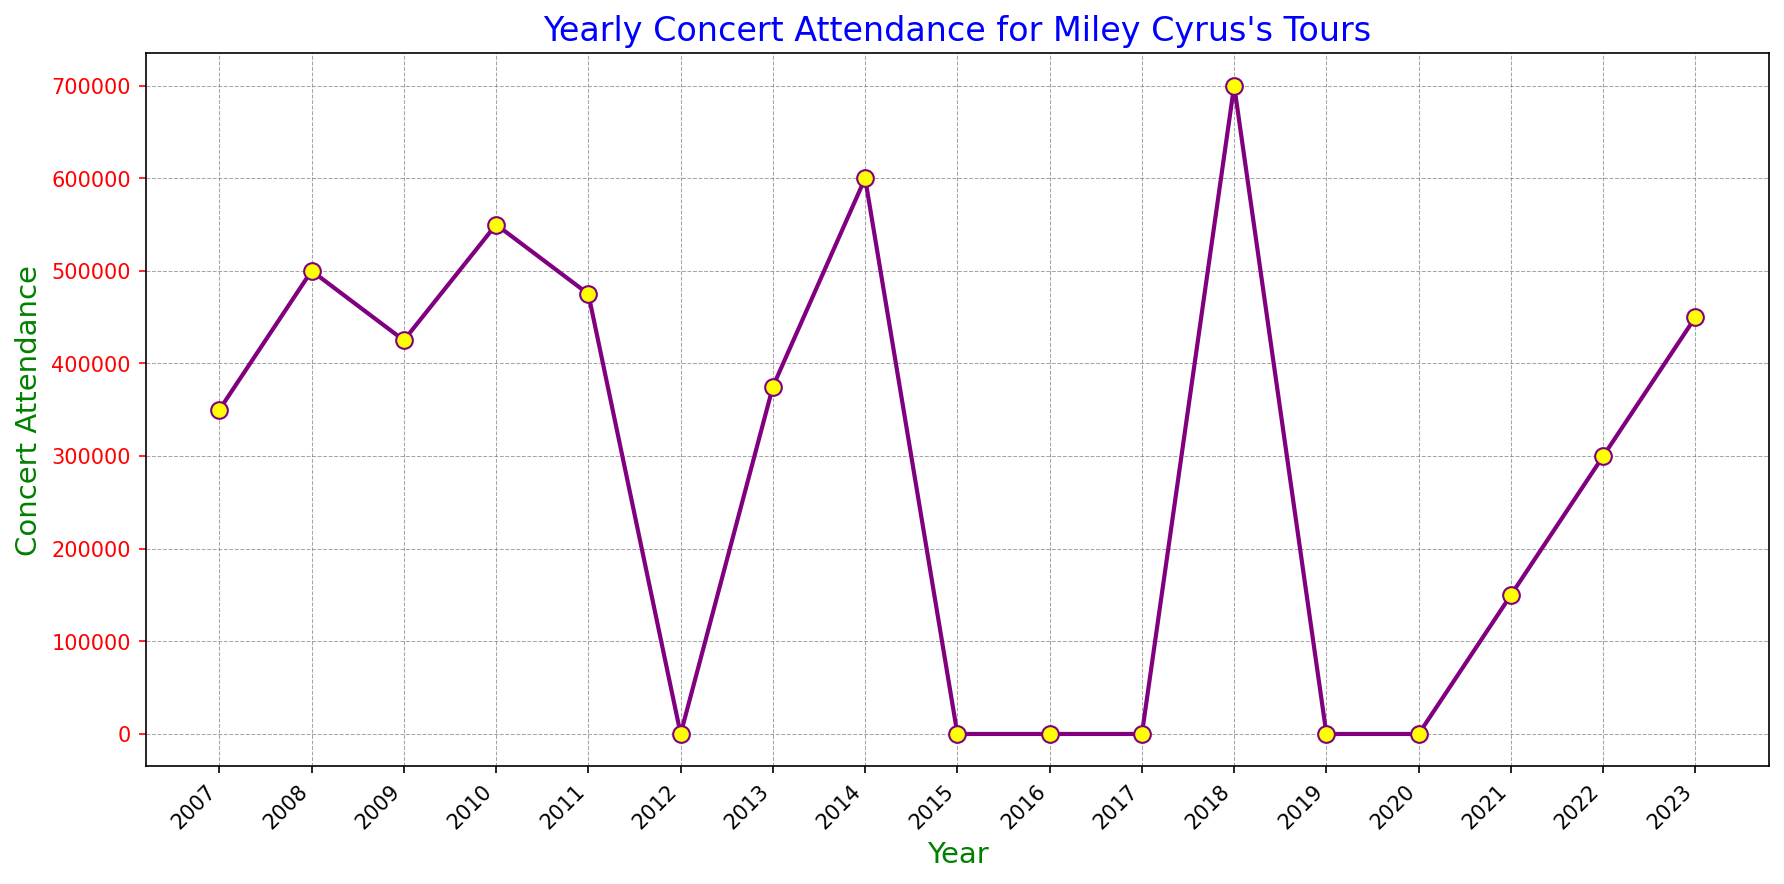What's the highest concert attendance year for Miley Cyrus? To find the highest concert attendance, look for the tallest point on the line graph. In this case, the tallest point represents the year 2018 with 700,000 attendees.
Answer: 2018 Which years did Miley Cyrus not have any concerts, resulting in zero attendance? The years with zero attendance can be identified by points on the graph lying at the bottommost line on the y-axis (0 attendance). These years are 2012, 2015, 2016, 2017, 2019, and 2020.
Answer: 2012, 2015, 2016, 2017, 2019, 2020 How did concert attendance change from 2007 to 2008? By examining the line's slope between 2007 and 2008, you'll see it goes upward, indicating an increase. Specifically, attendance increased from 350,000 to 500,000.
Answer: Increased In which year did Miley Cyrus experience the largest increase in concert attendance compared to the previous year? To identify the year with the largest increase, examine the differences between consecutive years. From 2017 to 2018, the increase was 700,000 - 0 = 700,000, which is the largest single-year increase.
Answer: 2018 What is the total concert attendance from 2007 to 2011? Summing the attendance numbers from 2007 to 2011: 350,000 + 500,000 + 425,000 + 550,000 + 475,000 = 2,300,000.
Answer: 2,300,000 During which span of years did Miley Cyrus not have any concerts, resulting in consistent zero attendance? Inspecting the graph, there is a span from 2016 to 2017 without concerts.
Answer: 2016 to 2017 Compare the concert attendance in 2014 and 2022. Which year had higher attendance, and by how much? Attendance in 2014 was 600,000 and in 2022 was 300,000. 2014 had higher attendance by 600,000 - 300,000 = 300,000.
Answer: 2014, 300,000 What is the average concert attendance in the years Miley Cyrus had concerts from 2007 to 2023? Sum the attendance values where there are concerts and divide by the number of years with concerts: (350,000 + 500,000 + 425,000 + 550,000 + 475,000 + 375,000 + 600,000 + 700,000 + 150,000 + 300,000 + 450,000) / 11 = 487,727.27.
Answer: 487,727.27 What is the difference in concert attendance between the years 2021 and 2023? The attendance in 2021 was 150,000 and in 2023 was 450,000, so the difference is 450,000 - 150,000 = 300,000.
Answer: 300,000 How many years experienced a decline in attendance compared to the previous year from 2007 to 2023? Examining the graph, the years with declining attendance compared to the previous are 2009, 2011, and 2013. Thus, there are 3 such years.
Answer: 3 